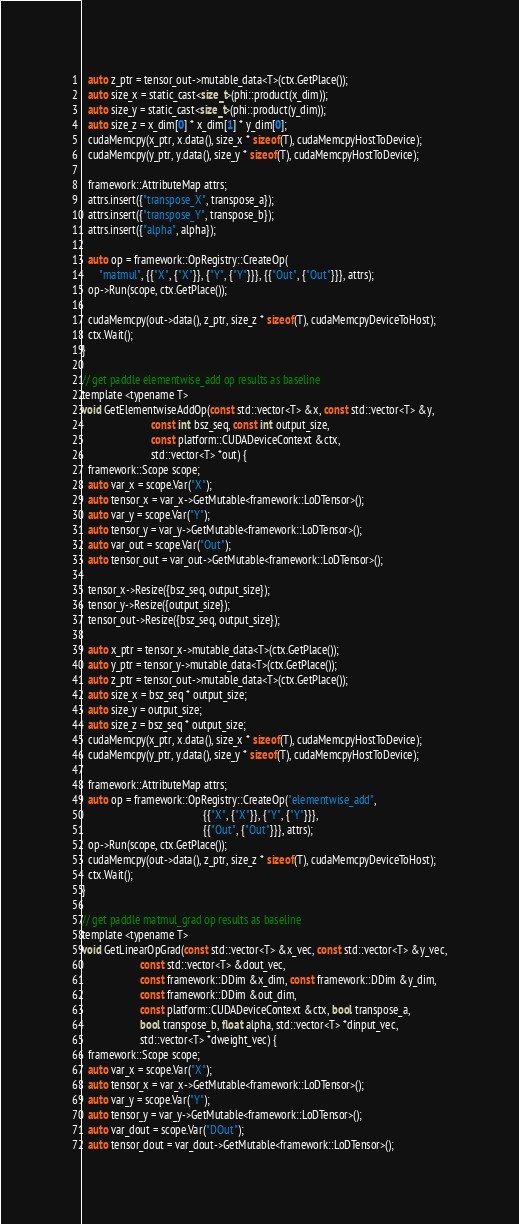<code> <loc_0><loc_0><loc_500><loc_500><_Cuda_>  auto z_ptr = tensor_out->mutable_data<T>(ctx.GetPlace());
  auto size_x = static_cast<size_t>(phi::product(x_dim));
  auto size_y = static_cast<size_t>(phi::product(y_dim));
  auto size_z = x_dim[0] * x_dim[1] * y_dim[0];
  cudaMemcpy(x_ptr, x.data(), size_x * sizeof(T), cudaMemcpyHostToDevice);
  cudaMemcpy(y_ptr, y.data(), size_y * sizeof(T), cudaMemcpyHostToDevice);

  framework::AttributeMap attrs;
  attrs.insert({"transpose_X", transpose_a});
  attrs.insert({"transpose_Y", transpose_b});
  attrs.insert({"alpha", alpha});

  auto op = framework::OpRegistry::CreateOp(
      "matmul", {{"X", {"X"}}, {"Y", {"Y"}}}, {{"Out", {"Out"}}}, attrs);
  op->Run(scope, ctx.GetPlace());

  cudaMemcpy(out->data(), z_ptr, size_z * sizeof(T), cudaMemcpyDeviceToHost);
  ctx.Wait();
}

// get paddle elementwise_add op results as baseline
template <typename T>
void GetElementwiseAddOp(const std::vector<T> &x, const std::vector<T> &y,
                         const int bsz_seq, const int output_size,
                         const platform::CUDADeviceContext &ctx,
                         std::vector<T> *out) {
  framework::Scope scope;
  auto var_x = scope.Var("X");
  auto tensor_x = var_x->GetMutable<framework::LoDTensor>();
  auto var_y = scope.Var("Y");
  auto tensor_y = var_y->GetMutable<framework::LoDTensor>();
  auto var_out = scope.Var("Out");
  auto tensor_out = var_out->GetMutable<framework::LoDTensor>();

  tensor_x->Resize({bsz_seq, output_size});
  tensor_y->Resize({output_size});
  tensor_out->Resize({bsz_seq, output_size});

  auto x_ptr = tensor_x->mutable_data<T>(ctx.GetPlace());
  auto y_ptr = tensor_y->mutable_data<T>(ctx.GetPlace());
  auto z_ptr = tensor_out->mutable_data<T>(ctx.GetPlace());
  auto size_x = bsz_seq * output_size;
  auto size_y = output_size;
  auto size_z = bsz_seq * output_size;
  cudaMemcpy(x_ptr, x.data(), size_x * sizeof(T), cudaMemcpyHostToDevice);
  cudaMemcpy(y_ptr, y.data(), size_y * sizeof(T), cudaMemcpyHostToDevice);

  framework::AttributeMap attrs;
  auto op = framework::OpRegistry::CreateOp("elementwise_add",
                                            {{"X", {"X"}}, {"Y", {"Y"}}},
                                            {{"Out", {"Out"}}}, attrs);
  op->Run(scope, ctx.GetPlace());
  cudaMemcpy(out->data(), z_ptr, size_z * sizeof(T), cudaMemcpyDeviceToHost);
  ctx.Wait();
}

// get paddle matmul_grad op results as baseline
template <typename T>
void GetLinearOpGrad(const std::vector<T> &x_vec, const std::vector<T> &y_vec,
                     const std::vector<T> &dout_vec,
                     const framework::DDim &x_dim, const framework::DDim &y_dim,
                     const framework::DDim &out_dim,
                     const platform::CUDADeviceContext &ctx, bool transpose_a,
                     bool transpose_b, float alpha, std::vector<T> *dinput_vec,
                     std::vector<T> *dweight_vec) {
  framework::Scope scope;
  auto var_x = scope.Var("X");
  auto tensor_x = var_x->GetMutable<framework::LoDTensor>();
  auto var_y = scope.Var("Y");
  auto tensor_y = var_y->GetMutable<framework::LoDTensor>();
  auto var_dout = scope.Var("DOut");
  auto tensor_dout = var_dout->GetMutable<framework::LoDTensor>();</code> 